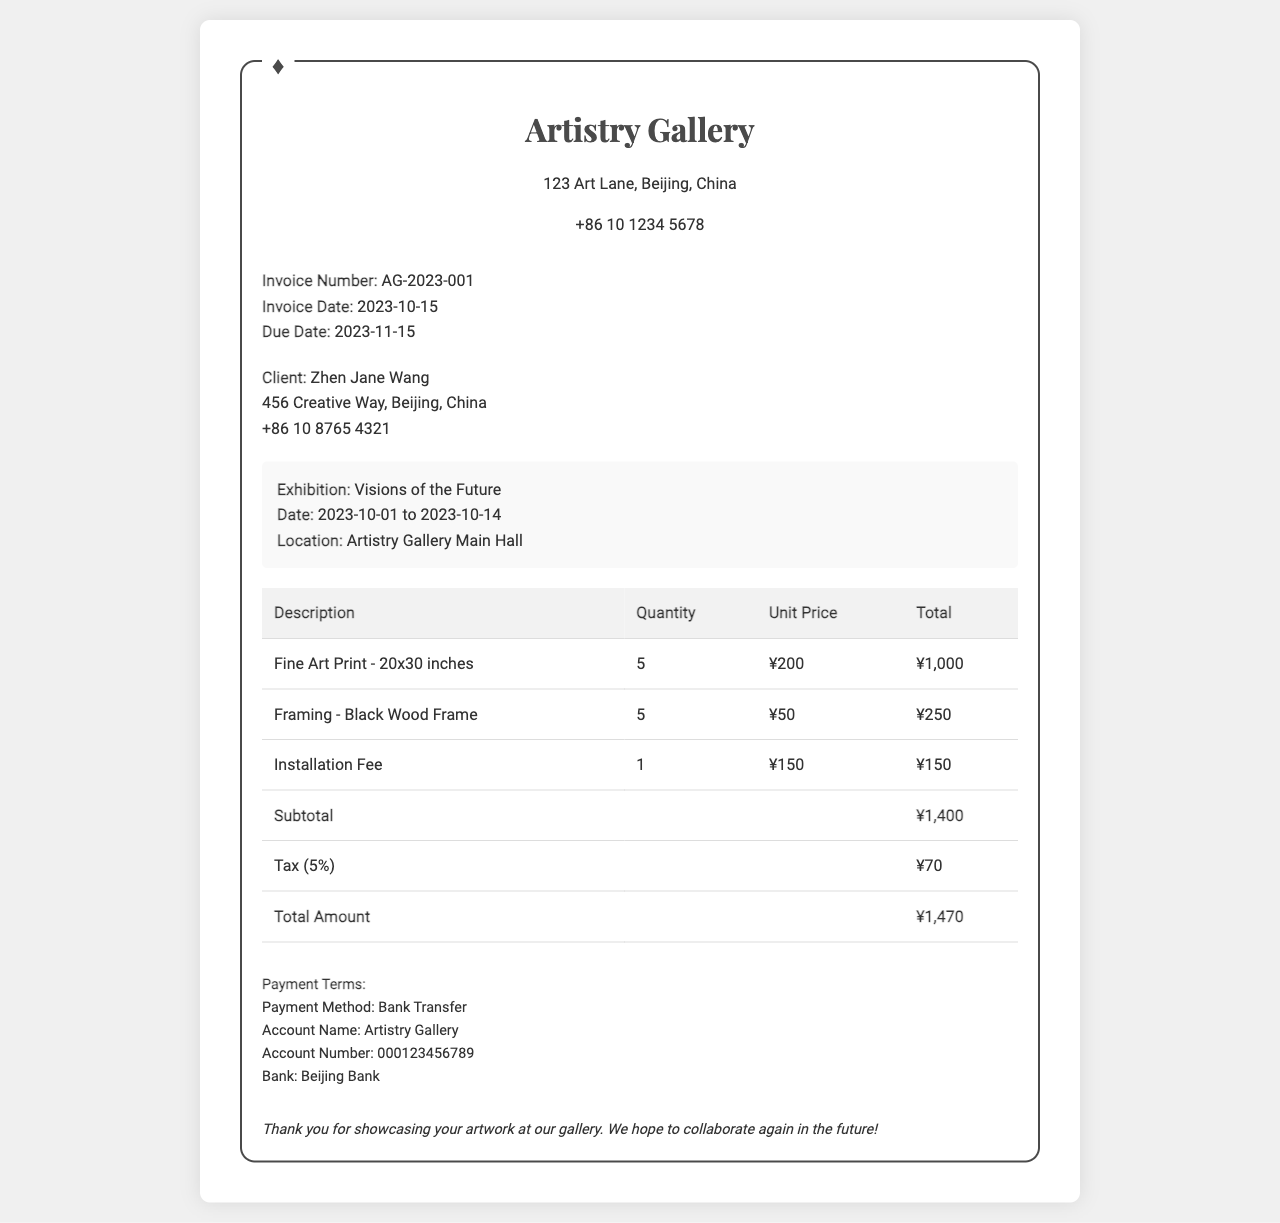What is the invoice number? The invoice number is specified in the document to uniquely identify the invoice.
Answer: AG-2023-001 What is the client's address? The client's address is mentioned in the document under the client info section.
Answer: 456 Creative Way, Beijing, China What is the unit price for the fine art print? The unit price for the fine art print is listed in the table as the price for one print.
Answer: ¥200 How many fine art prints were ordered? The quantity of fine art prints ordered can be found in the table under the quantity column.
Answer: 5 What is the tax amount? The tax amount is indicated in the table and is calculated based on the subtotal.
Answer: ¥70 What is the due date for the invoice? The due date is provided in the document to indicate when payment must be made.
Answer: 2023-11-15 What is the total amount due? The total amount due is the final cost listed at the bottom of the table, including tax.
Answer: ¥1,470 What payment method is accepted? The payment method is mentioned in the payment terms section of the invoice.
Answer: Bank Transfer How many items were framed? The number of items framed is specified in the description column of the invoice.
Answer: 5 